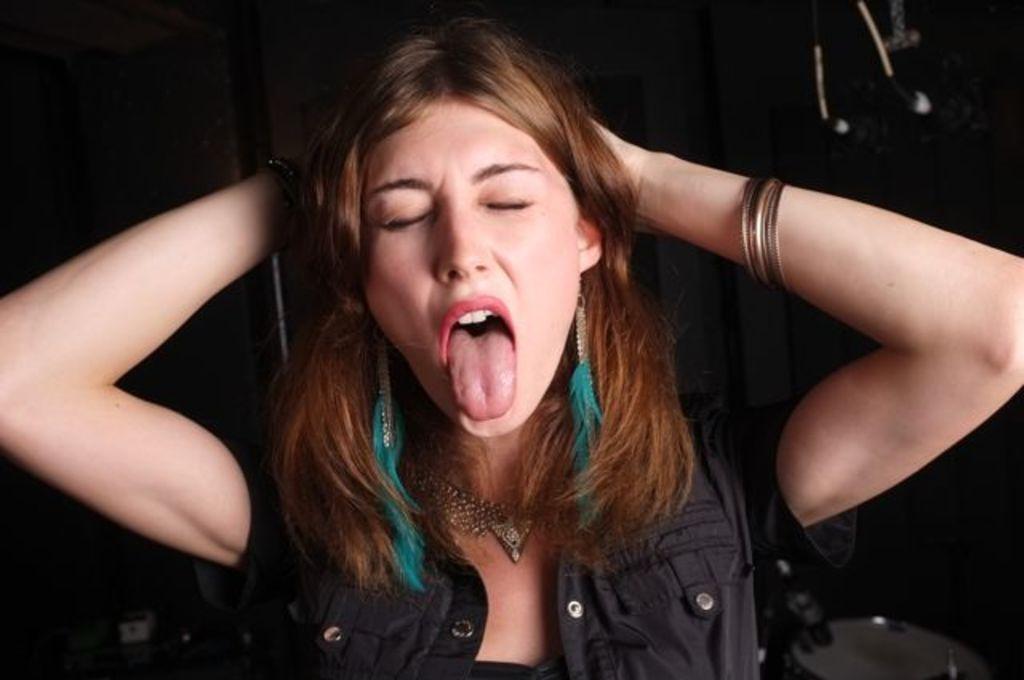Could you give a brief overview of what you see in this image? In this picture I can see a woman. The woman is wearing black color jacket and bangles in the hand. The background of the image is dark. 